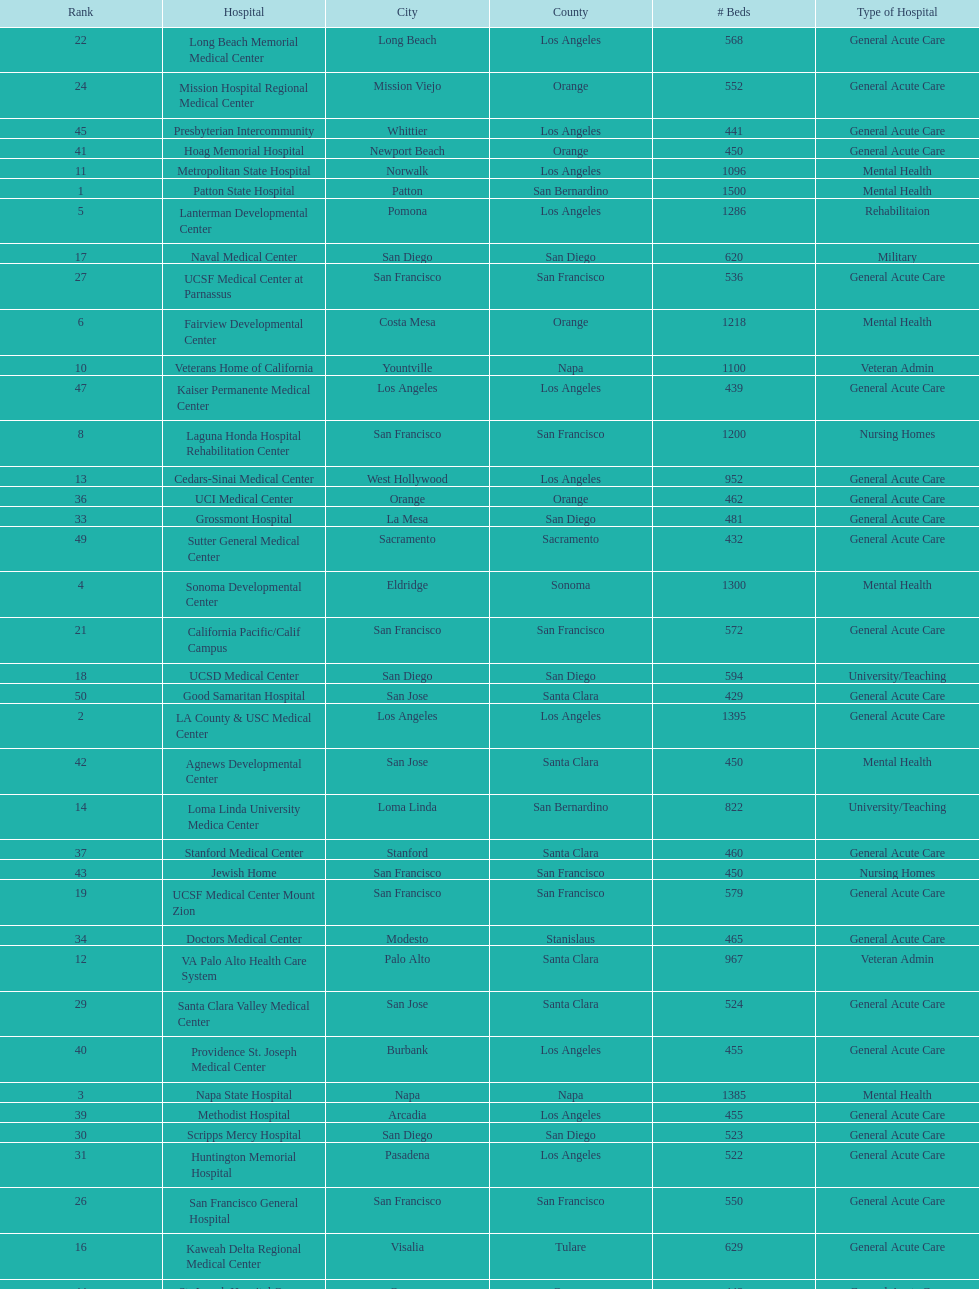How many hospital's have at least 600 beds? 17. 